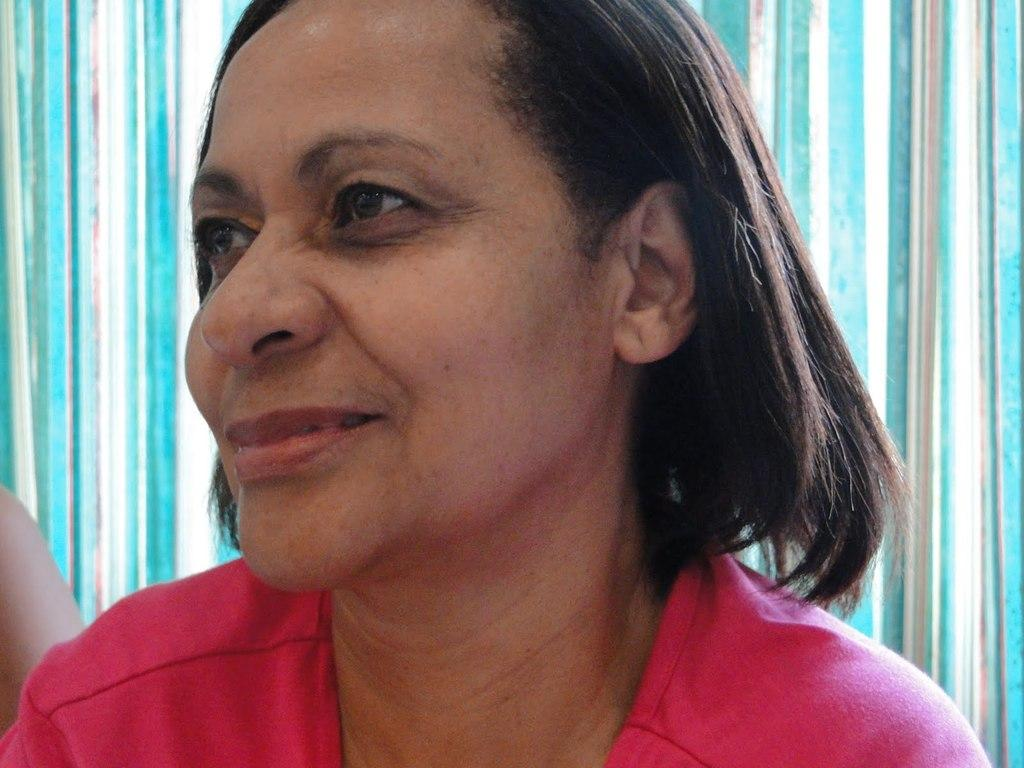Who is the main subject in the image? There is a lady in the image. What is the lady wearing? The lady is wearing a red dress. What can be seen in the background of the image? There is a blue color curtain in the background of the image. Where is the throne located in the image? There is no throne present in the image. Can you tell me who the guide is in the image? There is no guide present in the image. 